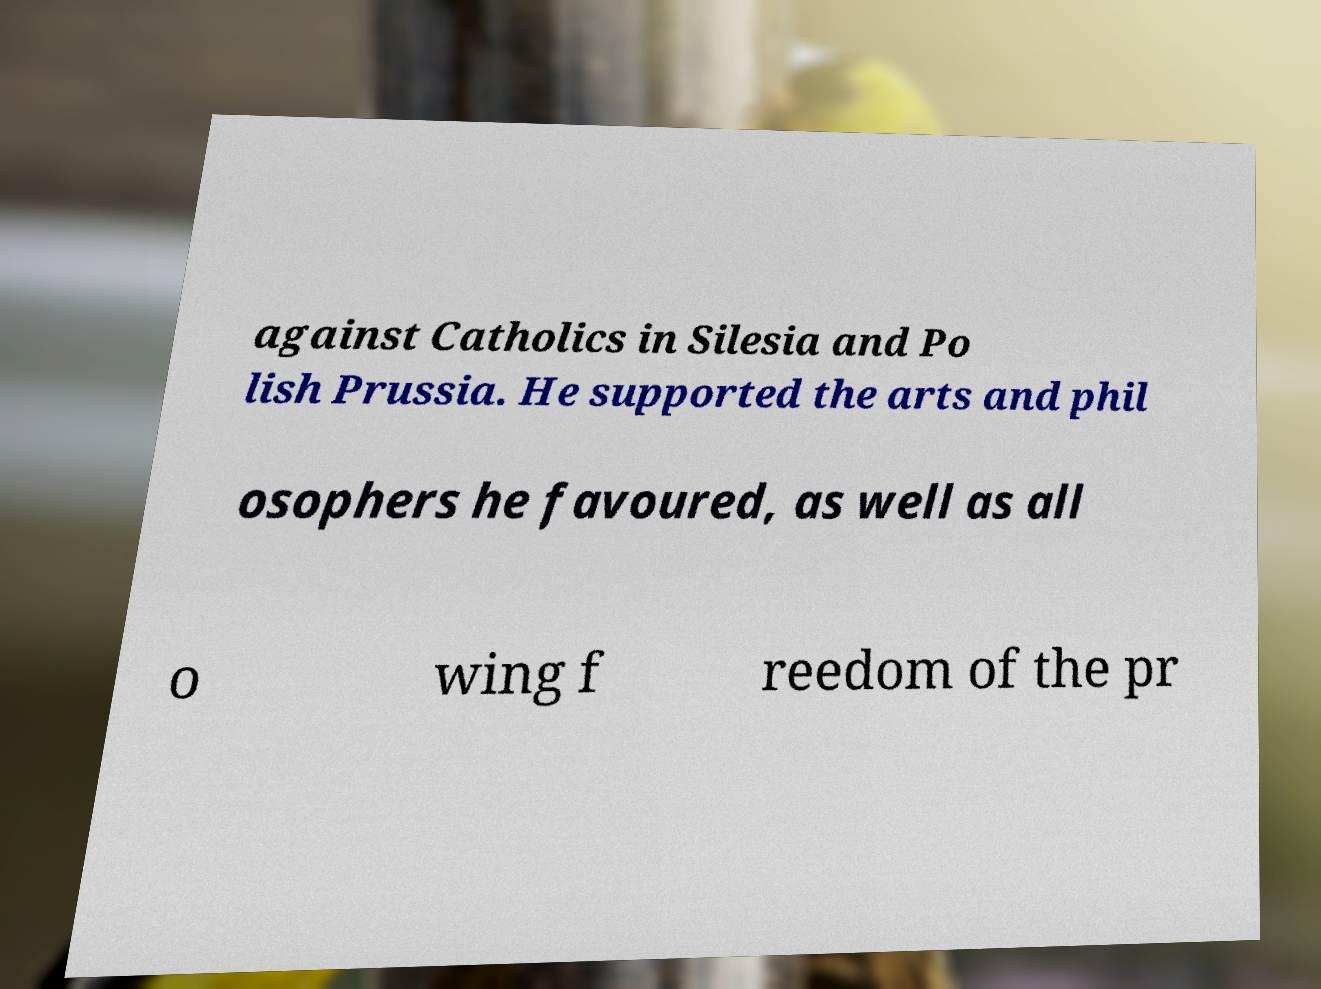I need the written content from this picture converted into text. Can you do that? against Catholics in Silesia and Po lish Prussia. He supported the arts and phil osophers he favoured, as well as all o wing f reedom of the pr 